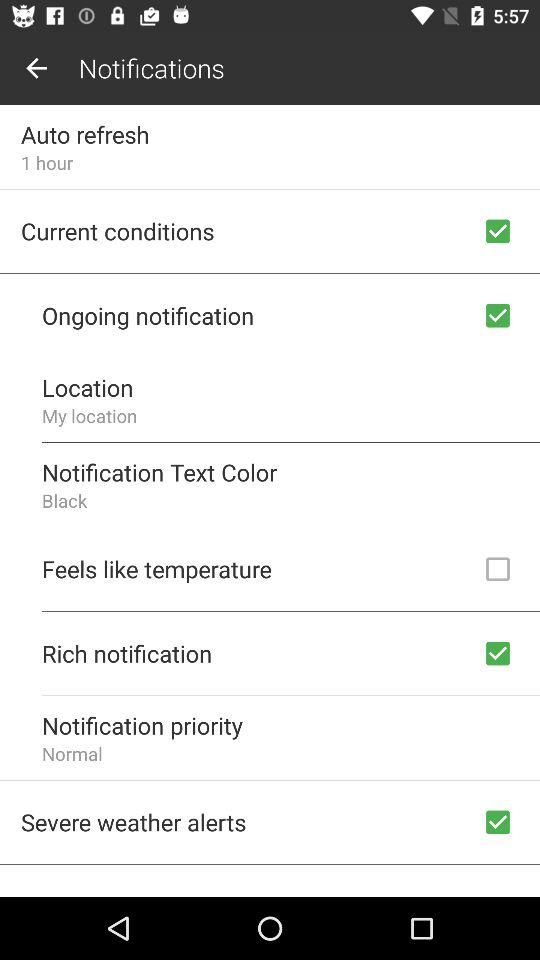What does the temperature feel like?
When the provided information is insufficient, respond with <no answer>. <no answer> 